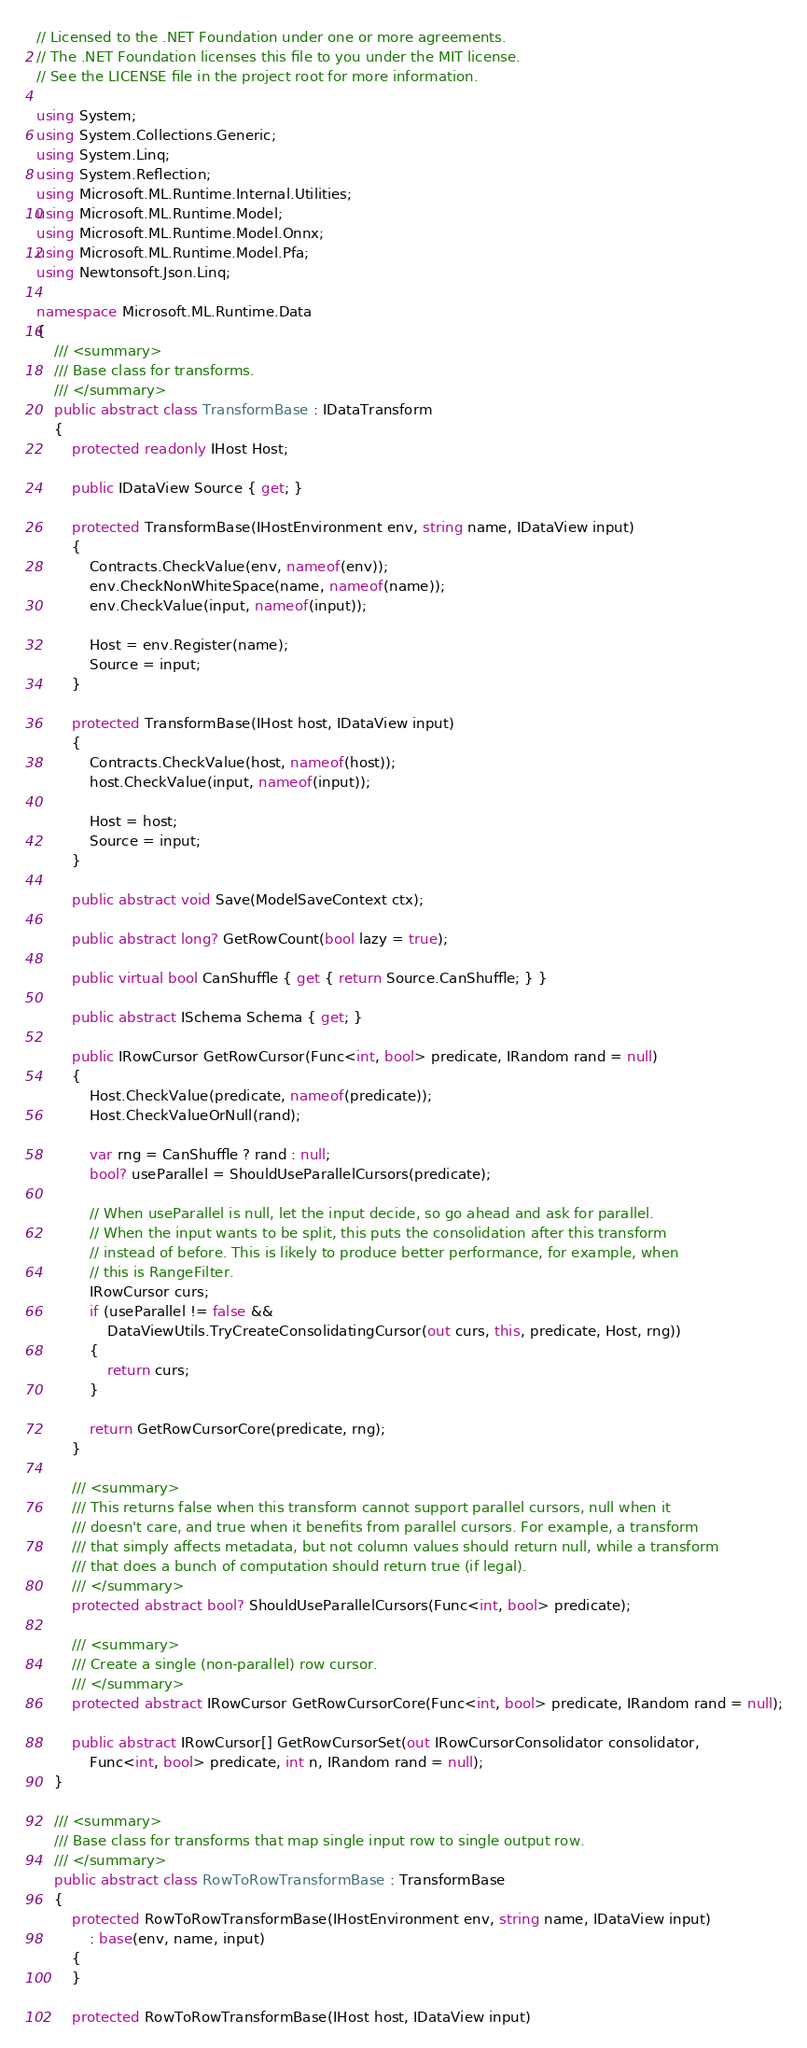Convert code to text. <code><loc_0><loc_0><loc_500><loc_500><_C#_>// Licensed to the .NET Foundation under one or more agreements.
// The .NET Foundation licenses this file to you under the MIT license.
// See the LICENSE file in the project root for more information.

using System;
using System.Collections.Generic;
using System.Linq;
using System.Reflection;
using Microsoft.ML.Runtime.Internal.Utilities;
using Microsoft.ML.Runtime.Model;
using Microsoft.ML.Runtime.Model.Onnx;
using Microsoft.ML.Runtime.Model.Pfa;
using Newtonsoft.Json.Linq;

namespace Microsoft.ML.Runtime.Data
{
    /// <summary>
    /// Base class for transforms.
    /// </summary>
    public abstract class TransformBase : IDataTransform
    {
        protected readonly IHost Host;

        public IDataView Source { get; }

        protected TransformBase(IHostEnvironment env, string name, IDataView input)
        {
            Contracts.CheckValue(env, nameof(env));
            env.CheckNonWhiteSpace(name, nameof(name));
            env.CheckValue(input, nameof(input));

            Host = env.Register(name);
            Source = input;
        }

        protected TransformBase(IHost host, IDataView input)
        {
            Contracts.CheckValue(host, nameof(host));
            host.CheckValue(input, nameof(input));

            Host = host;
            Source = input;
        }

        public abstract void Save(ModelSaveContext ctx);

        public abstract long? GetRowCount(bool lazy = true);

        public virtual bool CanShuffle { get { return Source.CanShuffle; } }

        public abstract ISchema Schema { get; }

        public IRowCursor GetRowCursor(Func<int, bool> predicate, IRandom rand = null)
        {
            Host.CheckValue(predicate, nameof(predicate));
            Host.CheckValueOrNull(rand);

            var rng = CanShuffle ? rand : null;
            bool? useParallel = ShouldUseParallelCursors(predicate);

            // When useParallel is null, let the input decide, so go ahead and ask for parallel.
            // When the input wants to be split, this puts the consolidation after this transform
            // instead of before. This is likely to produce better performance, for example, when
            // this is RangeFilter.
            IRowCursor curs;
            if (useParallel != false &&
                DataViewUtils.TryCreateConsolidatingCursor(out curs, this, predicate, Host, rng))
            {
                return curs;
            }

            return GetRowCursorCore(predicate, rng);
        }

        /// <summary>
        /// This returns false when this transform cannot support parallel cursors, null when it
        /// doesn't care, and true when it benefits from parallel cursors. For example, a transform
        /// that simply affects metadata, but not column values should return null, while a transform
        /// that does a bunch of computation should return true (if legal).
        /// </summary>
        protected abstract bool? ShouldUseParallelCursors(Func<int, bool> predicate);

        /// <summary>
        /// Create a single (non-parallel) row cursor.
        /// </summary>
        protected abstract IRowCursor GetRowCursorCore(Func<int, bool> predicate, IRandom rand = null);

        public abstract IRowCursor[] GetRowCursorSet(out IRowCursorConsolidator consolidator,
            Func<int, bool> predicate, int n, IRandom rand = null);
    }

    /// <summary>
    /// Base class for transforms that map single input row to single output row.
    /// </summary>
    public abstract class RowToRowTransformBase : TransformBase
    {
        protected RowToRowTransformBase(IHostEnvironment env, string name, IDataView input)
            : base(env, name, input)
        {
        }

        protected RowToRowTransformBase(IHost host, IDataView input)</code> 